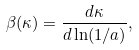<formula> <loc_0><loc_0><loc_500><loc_500>\beta ( \kappa ) = \frac { d \kappa } { d \ln ( 1 / a ) } ,</formula> 